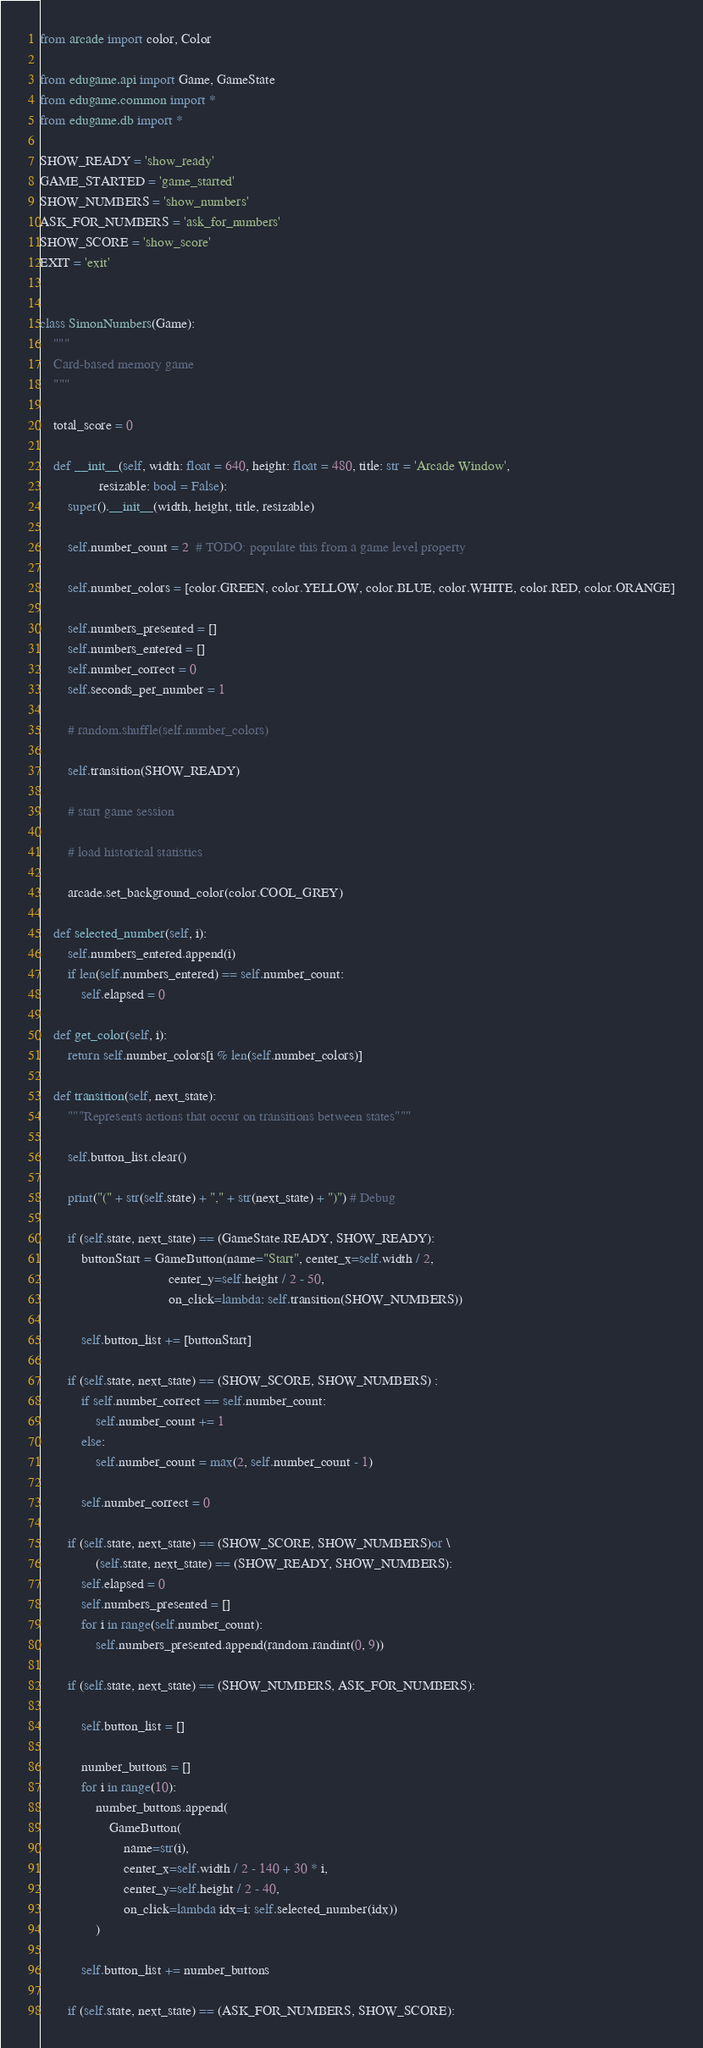<code> <loc_0><loc_0><loc_500><loc_500><_Python_>
from arcade import color, Color

from edugame.api import Game, GameState
from edugame.common import *
from edugame.db import *

SHOW_READY = 'show_ready'
GAME_STARTED = 'game_started'
SHOW_NUMBERS = 'show_numbers'
ASK_FOR_NUMBERS = 'ask_for_numbers'
SHOW_SCORE = 'show_score'
EXIT = 'exit'


class SimonNumbers(Game):
    """
    Card-based memory game
    """

    total_score = 0

    def __init__(self, width: float = 640, height: float = 480, title: str = 'Arcade Window',
                 resizable: bool = False):
        super().__init__(width, height, title, resizable)

        self.number_count = 2  # TODO: populate this from a game level property

        self.number_colors = [color.GREEN, color.YELLOW, color.BLUE, color.WHITE, color.RED, color.ORANGE]

        self.numbers_presented = []
        self.numbers_entered = []
        self.number_correct = 0
        self.seconds_per_number = 1

        # random.shuffle(self.number_colors)

        self.transition(SHOW_READY)

        # start game session

        # load historical statistics

        arcade.set_background_color(color.COOL_GREY)

    def selected_number(self, i):
        self.numbers_entered.append(i)
        if len(self.numbers_entered) == self.number_count:
            self.elapsed = 0

    def get_color(self, i):
        return self.number_colors[i % len(self.number_colors)]

    def transition(self, next_state):
        """Represents actions that occur on transitions between states"""

        self.button_list.clear()

        print("(" + str(self.state) + "," + str(next_state) + ")") # Debug

        if (self.state, next_state) == (GameState.READY, SHOW_READY):
            buttonStart = GameButton(name="Start", center_x=self.width / 2,
                                     center_y=self.height / 2 - 50,
                                     on_click=lambda: self.transition(SHOW_NUMBERS))

            self.button_list += [buttonStart]

        if (self.state, next_state) == (SHOW_SCORE, SHOW_NUMBERS) :
            if self.number_correct == self.number_count:
                self.number_count += 1
            else:
                self.number_count = max(2, self.number_count - 1)

            self.number_correct = 0

        if (self.state, next_state) == (SHOW_SCORE, SHOW_NUMBERS)or \
                (self.state, next_state) == (SHOW_READY, SHOW_NUMBERS):
            self.elapsed = 0
            self.numbers_presented = []
            for i in range(self.number_count):
                self.numbers_presented.append(random.randint(0, 9))

        if (self.state, next_state) == (SHOW_NUMBERS, ASK_FOR_NUMBERS):

            self.button_list = []

            number_buttons = []
            for i in range(10):
                number_buttons.append(
                    GameButton(
                        name=str(i),
                        center_x=self.width / 2 - 140 + 30 * i,
                        center_y=self.height / 2 - 40,
                        on_click=lambda idx=i: self.selected_number(idx))
                )

            self.button_list += number_buttons

        if (self.state, next_state) == (ASK_FOR_NUMBERS, SHOW_SCORE):
</code> 